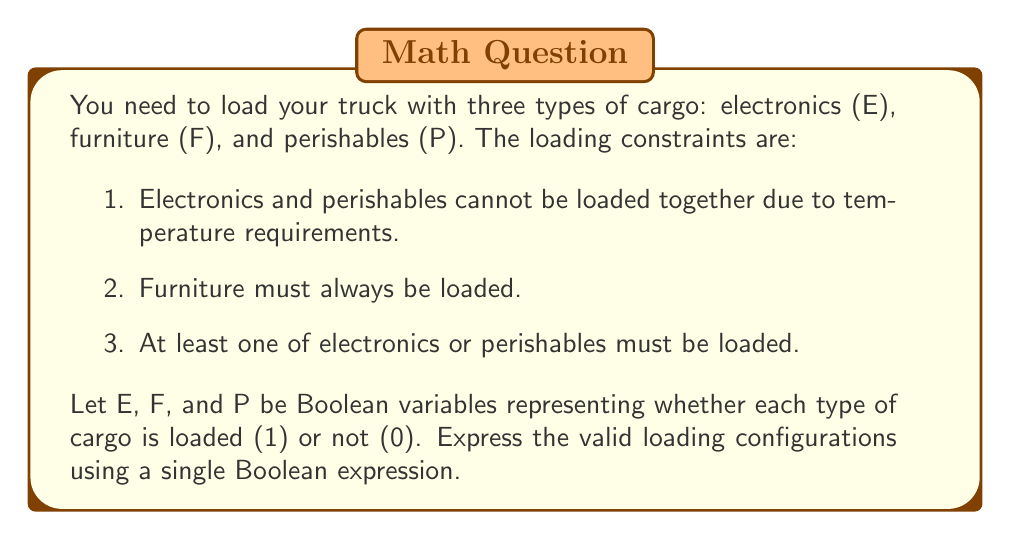What is the answer to this math problem? Let's break this down step-by-step:

1. Electronics and perishables cannot be loaded together:
   This can be expressed as $$(E \land \lnot P) \lor (\lnot E \land P)$$
   Or more concisely as $E \oplus P$ (exclusive OR)

2. Furniture must always be loaded:
   This is simply expressed as $F$

3. At least one of electronics or perishables must be loaded:
   This can be expressed as $E \lor P$

Now, we need to combine these conditions using logical AND ($\land$):

$$(E \oplus P) \land F \land (E \lor P)$$

We can simplify this further:
$$(E \oplus P) \land (E \lor P)$$ is logically equivalent to just $(E \oplus P)$,
because if $E \oplus P$ is true, then $E \lor P$ must also be true.

Therefore, our final Boolean expression is:

$$(E \oplus P) \land F$$

This expression will be true (1) for all valid loading configurations and false (0) for invalid ones.
Answer: $(E \oplus P) \land F$ 